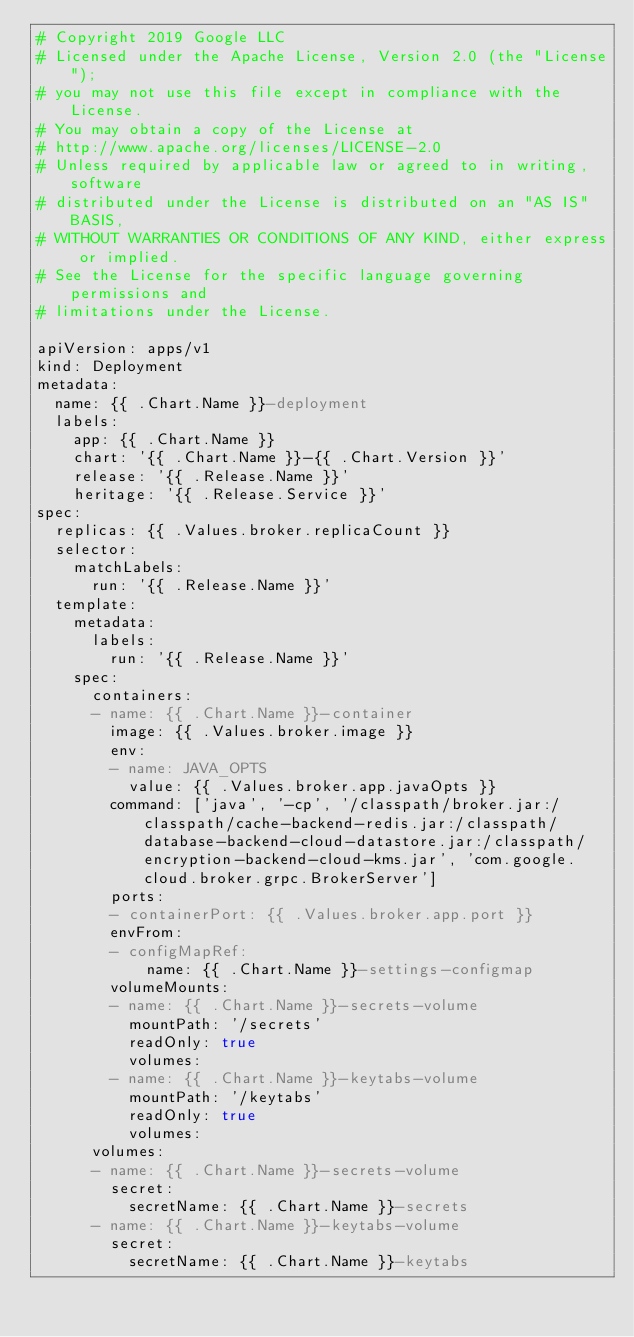<code> <loc_0><loc_0><loc_500><loc_500><_YAML_># Copyright 2019 Google LLC
# Licensed under the Apache License, Version 2.0 (the "License");
# you may not use this file except in compliance with the License.
# You may obtain a copy of the License at
# http://www.apache.org/licenses/LICENSE-2.0
# Unless required by applicable law or agreed to in writing, software
# distributed under the License is distributed on an "AS IS" BASIS,
# WITHOUT WARRANTIES OR CONDITIONS OF ANY KIND, either express or implied.
# See the License for the specific language governing permissions and
# limitations under the License.

apiVersion: apps/v1
kind: Deployment
metadata:
  name: {{ .Chart.Name }}-deployment
  labels:
    app: {{ .Chart.Name }}
    chart: '{{ .Chart.Name }}-{{ .Chart.Version }}'
    release: '{{ .Release.Name }}'
    heritage: '{{ .Release.Service }}'
spec:
  replicas: {{ .Values.broker.replicaCount }}
  selector:
    matchLabels:
      run: '{{ .Release.Name }}'
  template:
    metadata:
      labels:
        run: '{{ .Release.Name }}'
    spec:
      containers:
      - name: {{ .Chart.Name }}-container
        image: {{ .Values.broker.image }}
        env:
        - name: JAVA_OPTS
          value: {{ .Values.broker.app.javaOpts }}
        command: ['java', '-cp', '/classpath/broker.jar:/classpath/cache-backend-redis.jar:/classpath/database-backend-cloud-datastore.jar:/classpath/encryption-backend-cloud-kms.jar', 'com.google.cloud.broker.grpc.BrokerServer']
        ports:
        - containerPort: {{ .Values.broker.app.port }}
        envFrom:
        - configMapRef:
            name: {{ .Chart.Name }}-settings-configmap
        volumeMounts:
        - name: {{ .Chart.Name }}-secrets-volume
          mountPath: '/secrets'
          readOnly: true
          volumes:
        - name: {{ .Chart.Name }}-keytabs-volume
          mountPath: '/keytabs'
          readOnly: true
          volumes:
      volumes:
      - name: {{ .Chart.Name }}-secrets-volume
        secret:
          secretName: {{ .Chart.Name }}-secrets
      - name: {{ .Chart.Name }}-keytabs-volume
        secret:
          secretName: {{ .Chart.Name }}-keytabs</code> 